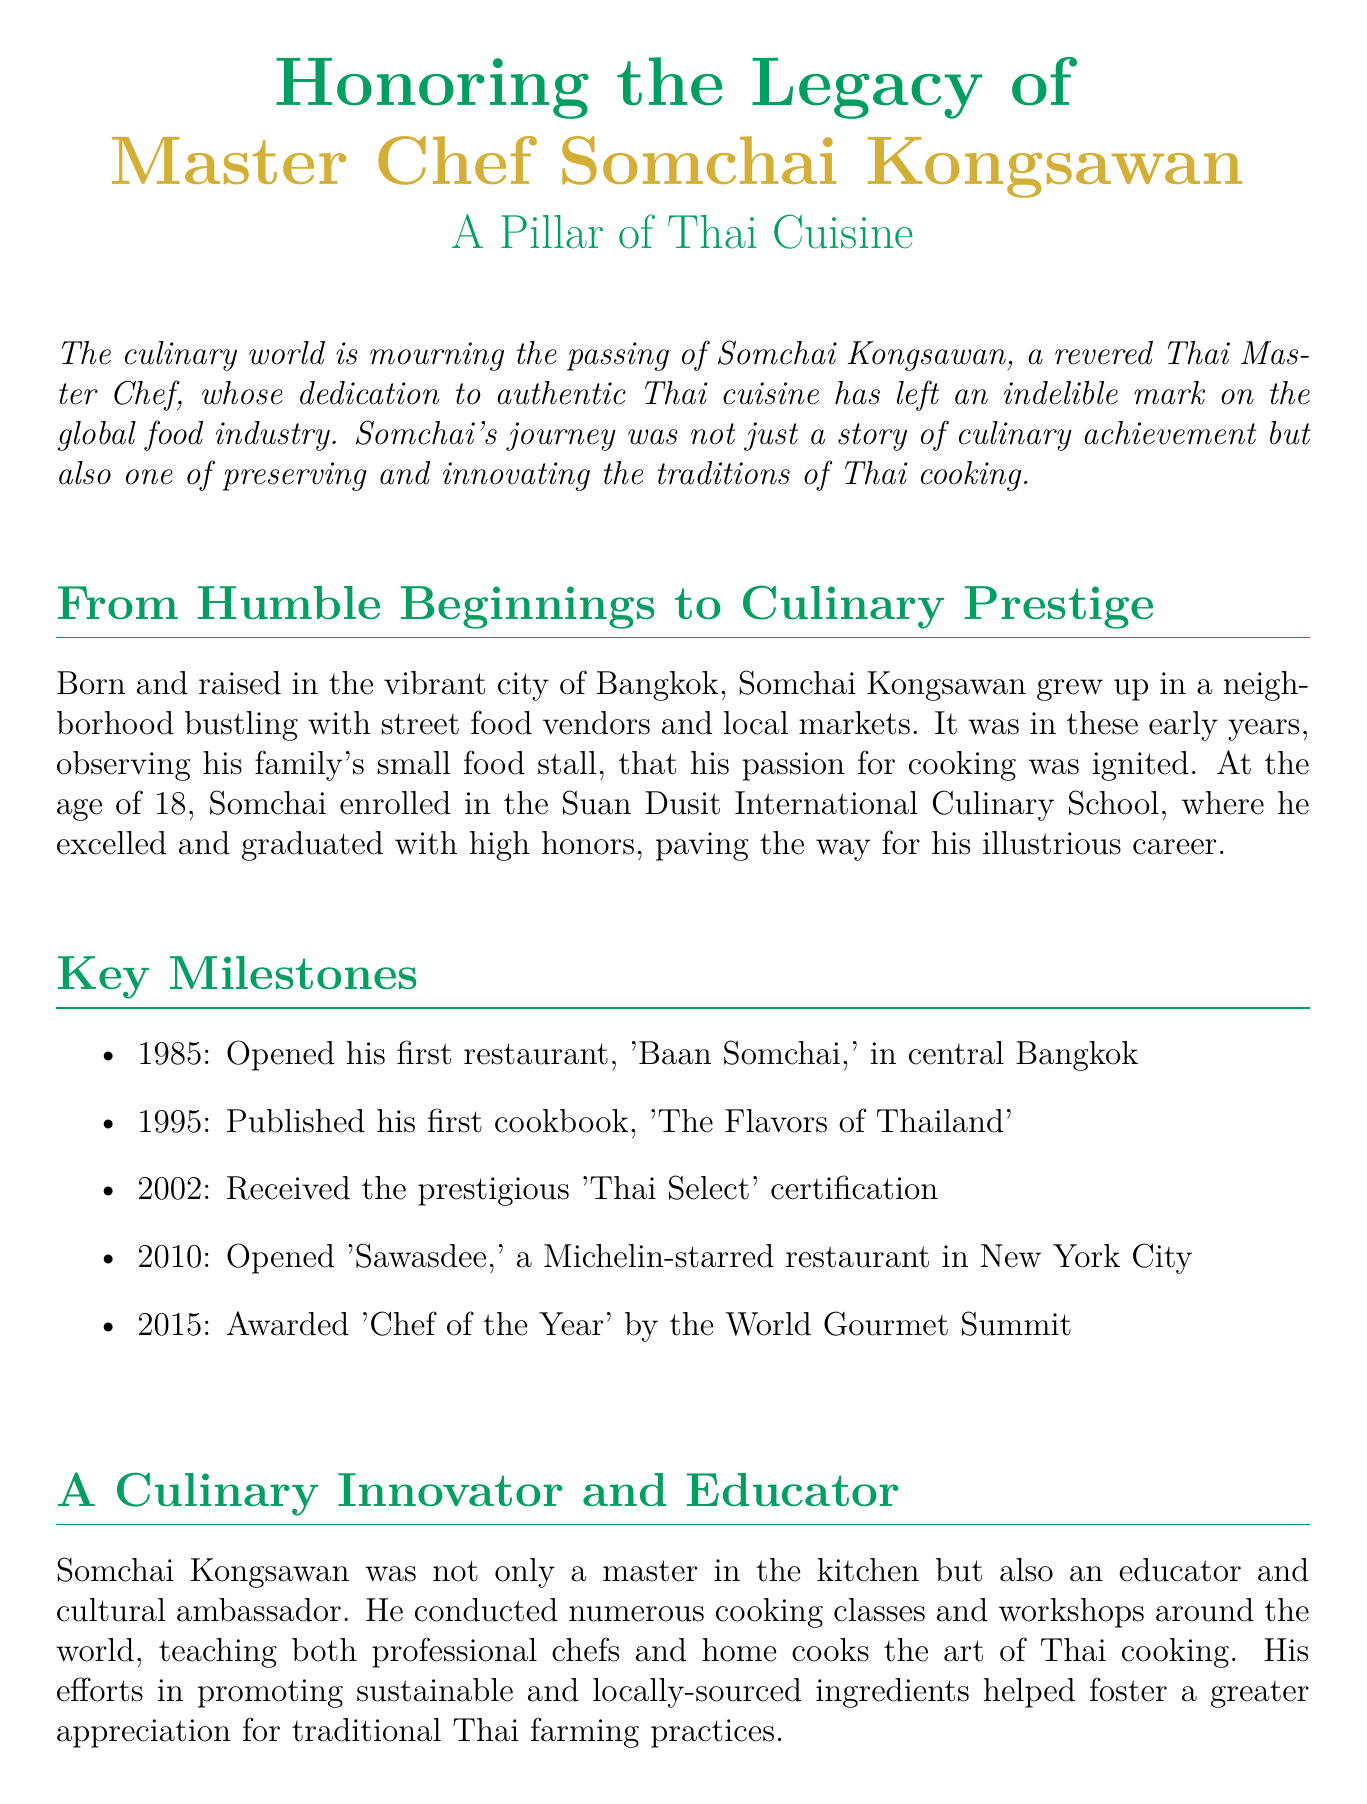What was Master Chef Somchai Kongsawan's first restaurant? The document states that his first restaurant was 'Baan Somchai,' which he opened in central Bangkok.
Answer: 'Baan Somchai' In what year did Somchai publish his first cookbook? According to the document, Somchai published his first cookbook titled 'The Flavors of Thailand' in 1995.
Answer: 1995 What prestigious certification did Somchai receive in 2002? The document mentions that Somchai received the 'Thai Select' certification in 2002.
Answer: 'Thai Select' How many years after opening his first restaurant did Somchai open 'Sawasdee'? The information shows that he opened 'Sawasdee' in 2010, five years after he opened 'Baan Somchai' in 1985, indicating a gap of 25 years.
Answer: 25 years What did Chef Arun Sampanthavivat say about Somchai? The document quotes Arun Sampanthavivat saying, "Somchai had a unique ability to blend tradition and innovation."
Answer: "blend tradition and innovation" What was a key focus of Somchai's cooking classes? The document highlights that Somchai's cooking classes focused on promoting sustainable and locally-sourced ingredients.
Answer: sustainable and locally-sourced ingredients What award did Somchai receive in 2015? The document notes that Somchai was awarded 'Chef of the Year' by the World Gourmet Summit in 2015.
Answer: 'Chef of the Year' What type of document is this? The content presented follows the format and characteristics typical to an obituary.
Answer: obituary What city was Somchai born in? The document indicates that Somchai Kongsawan was born and raised in Bangkok.
Answer: Bangkok 